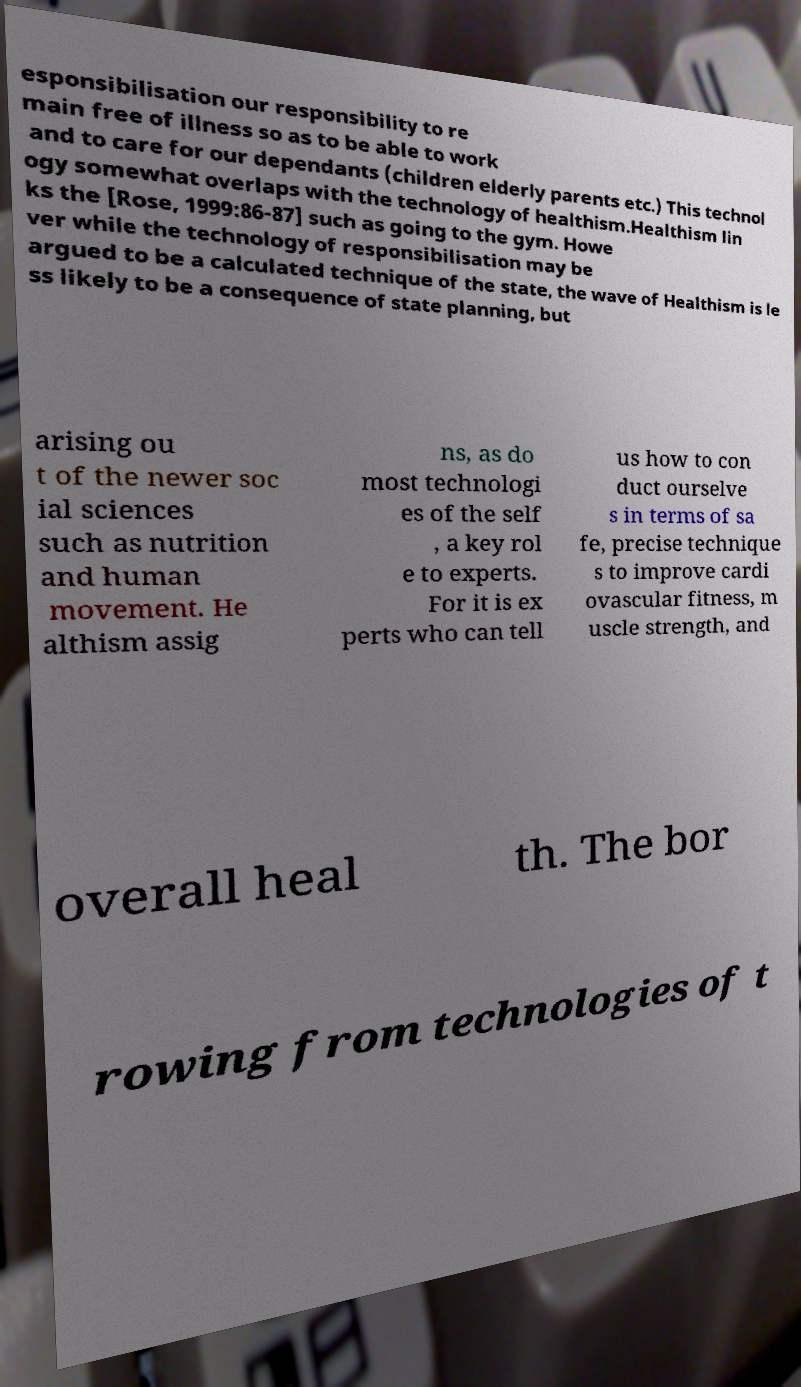There's text embedded in this image that I need extracted. Can you transcribe it verbatim? esponsibilisation our responsibility to re main free of illness so as to be able to work and to care for our dependants (children elderly parents etc.) This technol ogy somewhat overlaps with the technology of healthism.Healthism lin ks the [Rose, 1999:86-87] such as going to the gym. Howe ver while the technology of responsibilisation may be argued to be a calculated technique of the state, the wave of Healthism is le ss likely to be a consequence of state planning, but arising ou t of the newer soc ial sciences such as nutrition and human movement. He althism assig ns, as do most technologi es of the self , a key rol e to experts. For it is ex perts who can tell us how to con duct ourselve s in terms of sa fe, precise technique s to improve cardi ovascular fitness, m uscle strength, and overall heal th. The bor rowing from technologies of t 